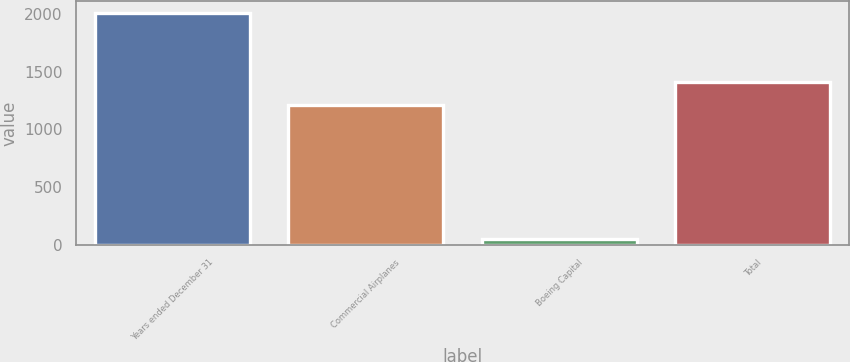Convert chart. <chart><loc_0><loc_0><loc_500><loc_500><bar_chart><fcel>Years ended December 31<fcel>Commercial Airplanes<fcel>Boeing Capital<fcel>Total<nl><fcel>2012<fcel>1215<fcel>49<fcel>1411.3<nl></chart> 